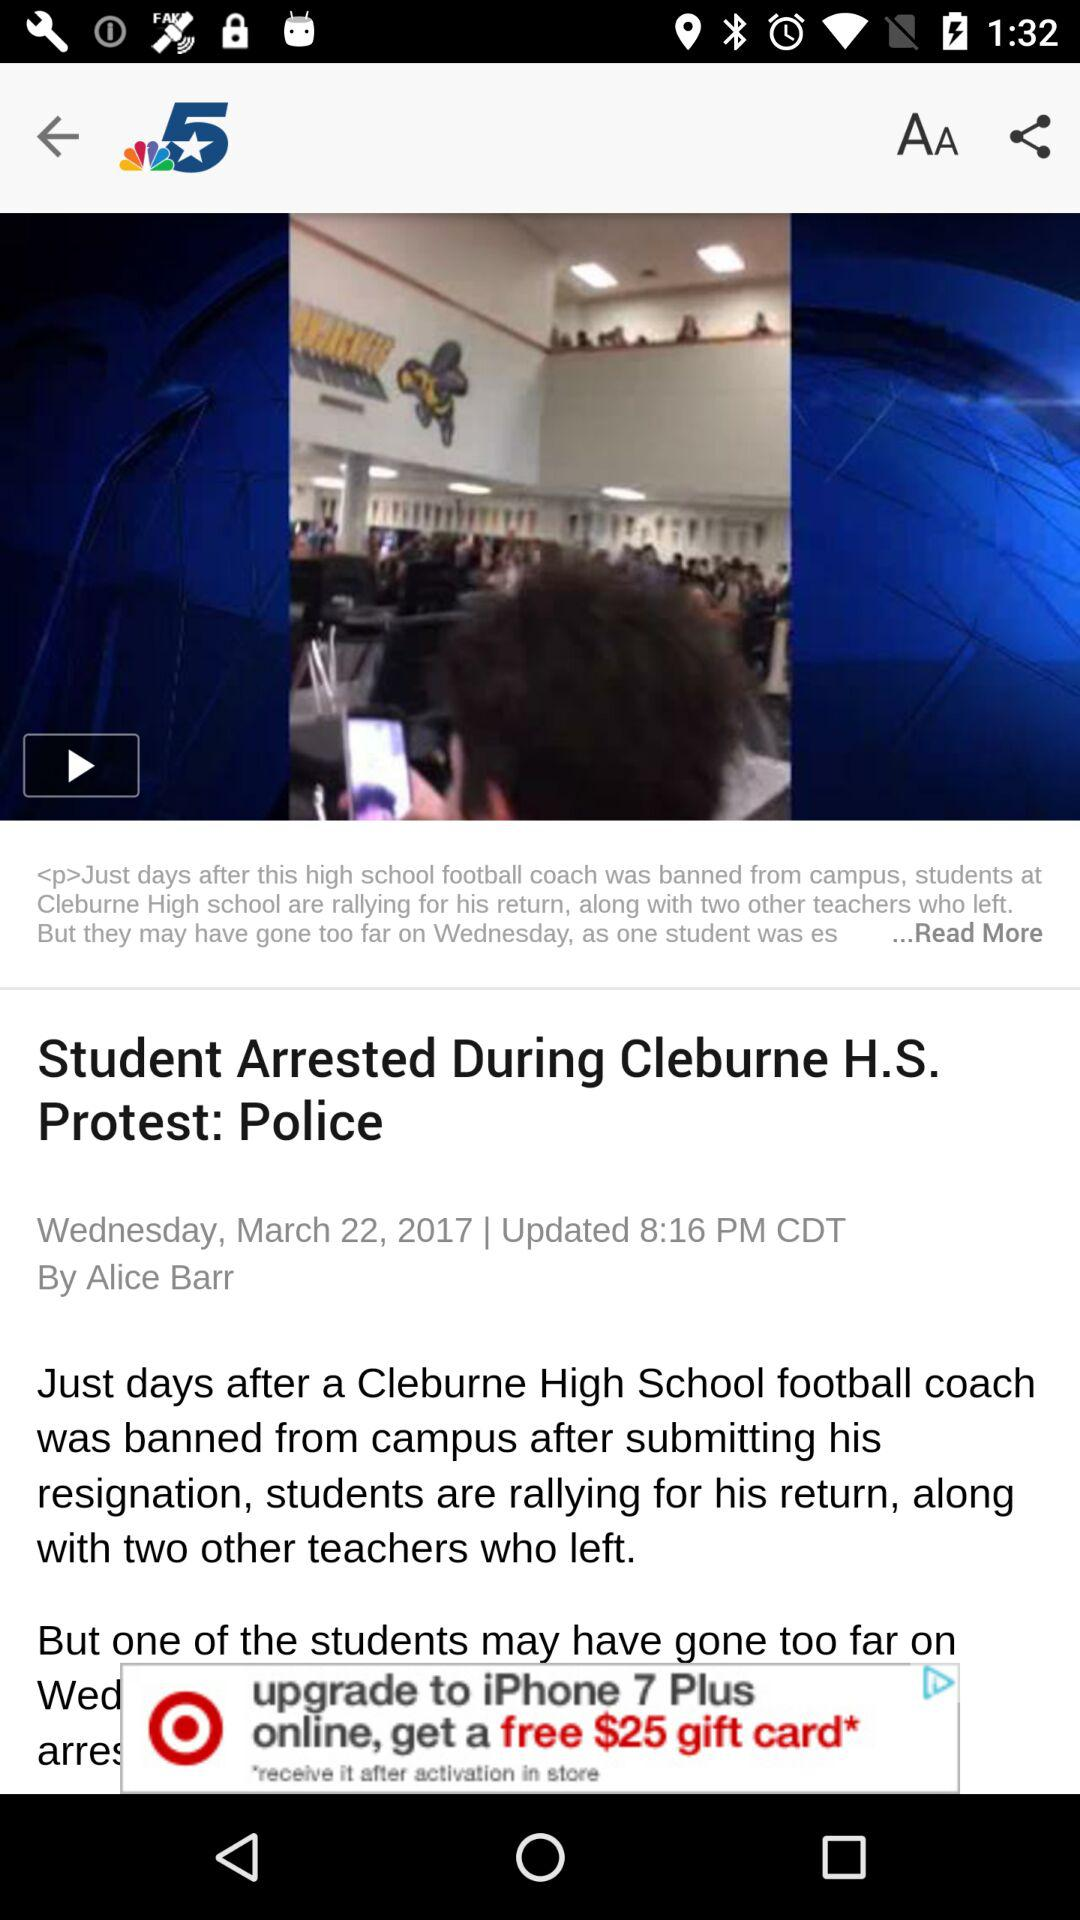In which year was this news published? The news was published in 2017. 